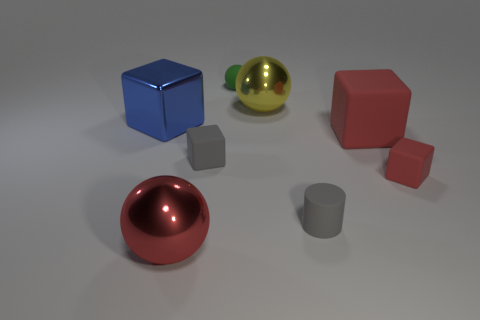Subtract 1 cubes. How many cubes are left? 3 Add 1 tiny gray blocks. How many objects exist? 9 Subtract all balls. How many objects are left? 5 Add 7 tiny green rubber spheres. How many tiny green rubber spheres are left? 8 Add 4 tiny red rubber things. How many tiny red rubber things exist? 5 Subtract 0 cyan cubes. How many objects are left? 8 Subtract all small gray matte spheres. Subtract all red rubber blocks. How many objects are left? 6 